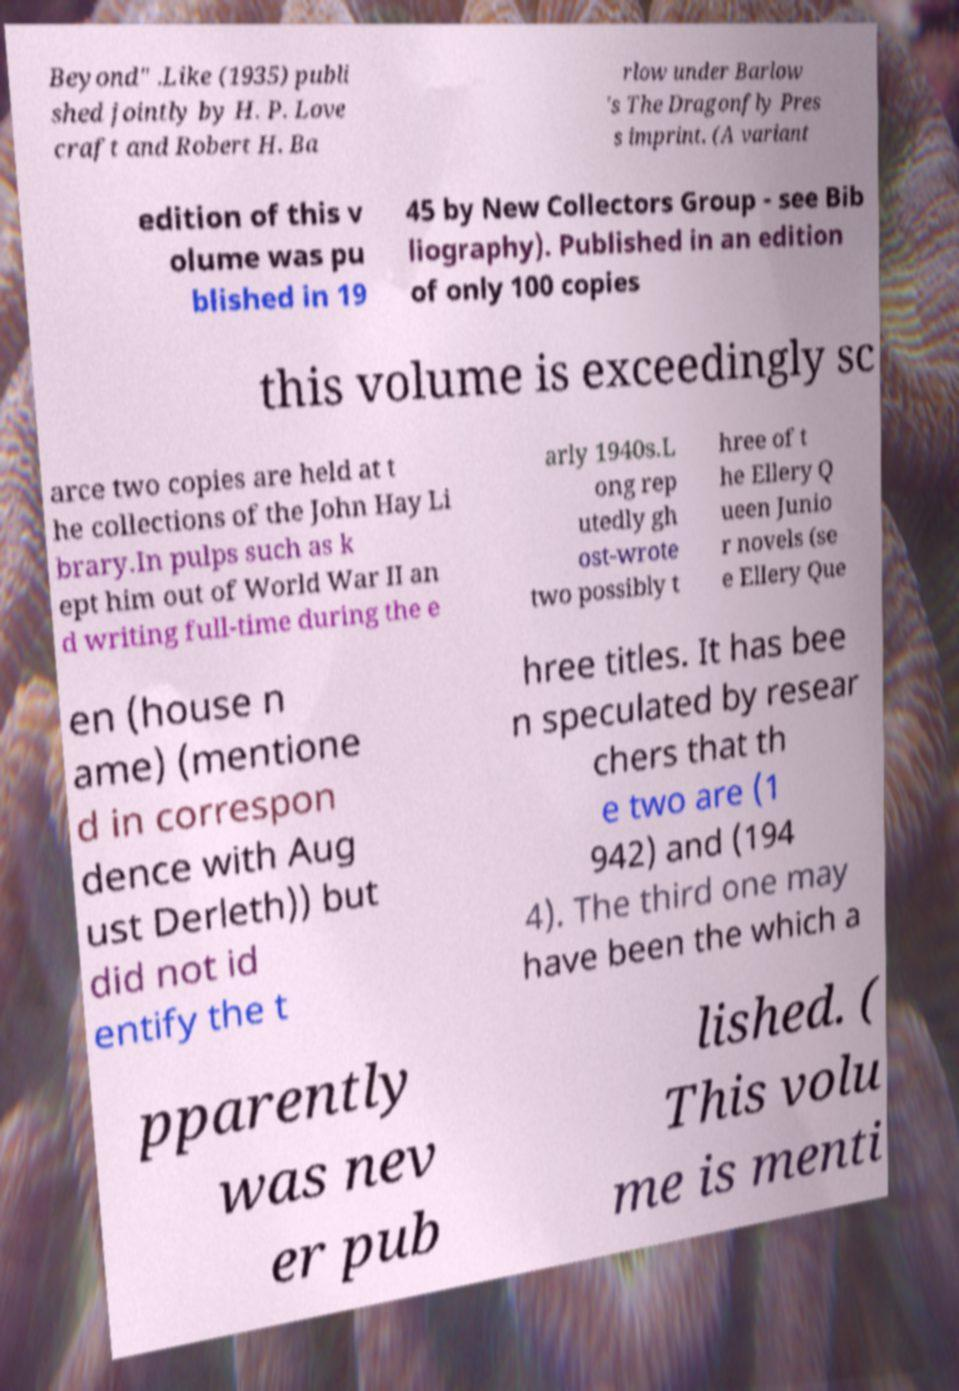What messages or text are displayed in this image? I need them in a readable, typed format. Beyond" .Like (1935) publi shed jointly by H. P. Love craft and Robert H. Ba rlow under Barlow 's The Dragonfly Pres s imprint. (A variant edition of this v olume was pu blished in 19 45 by New Collectors Group - see Bib liography). Published in an edition of only 100 copies this volume is exceedingly sc arce two copies are held at t he collections of the John Hay Li brary.In pulps such as k ept him out of World War II an d writing full-time during the e arly 1940s.L ong rep utedly gh ost-wrote two possibly t hree of t he Ellery Q ueen Junio r novels (se e Ellery Que en (house n ame) (mentione d in correspon dence with Aug ust Derleth)) but did not id entify the t hree titles. It has bee n speculated by resear chers that th e two are (1 942) and (194 4). The third one may have been the which a pparently was nev er pub lished. ( This volu me is menti 